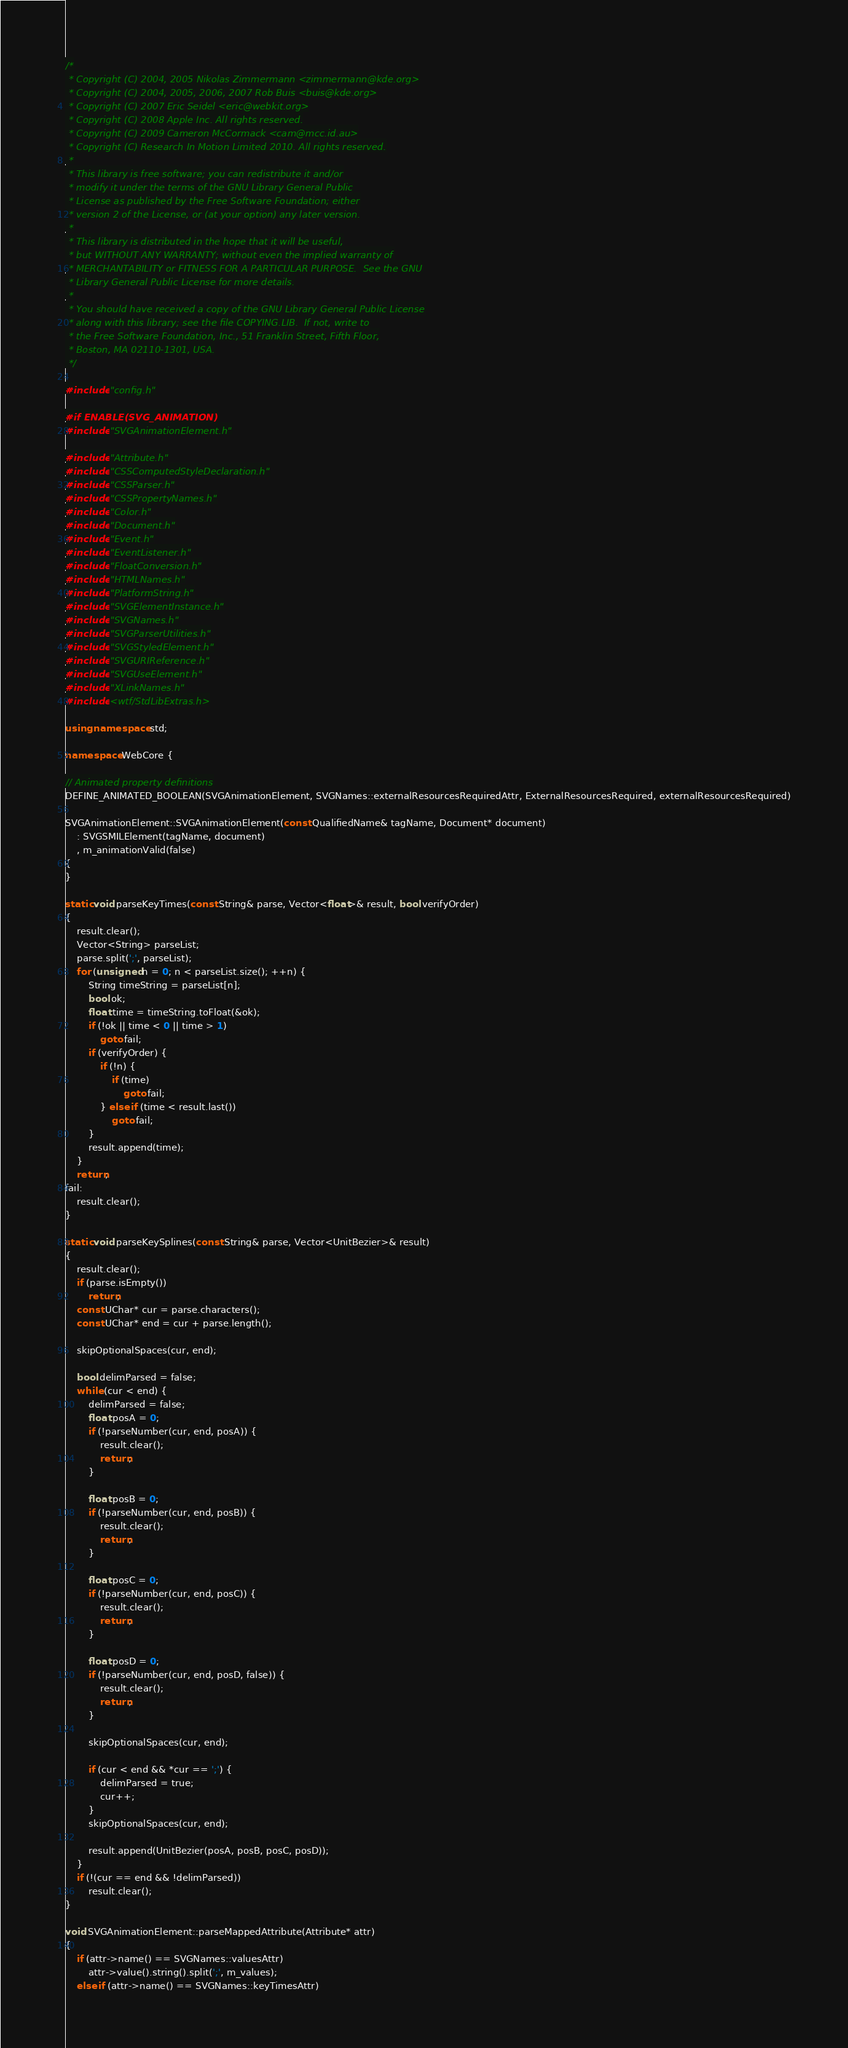<code> <loc_0><loc_0><loc_500><loc_500><_C++_>/*
 * Copyright (C) 2004, 2005 Nikolas Zimmermann <zimmermann@kde.org>
 * Copyright (C) 2004, 2005, 2006, 2007 Rob Buis <buis@kde.org>
 * Copyright (C) 2007 Eric Seidel <eric@webkit.org>
 * Copyright (C) 2008 Apple Inc. All rights reserved.
 * Copyright (C) 2009 Cameron McCormack <cam@mcc.id.au>
 * Copyright (C) Research In Motion Limited 2010. All rights reserved.
 *
 * This library is free software; you can redistribute it and/or
 * modify it under the terms of the GNU Library General Public
 * License as published by the Free Software Foundation; either
 * version 2 of the License, or (at your option) any later version.
 *
 * This library is distributed in the hope that it will be useful,
 * but WITHOUT ANY WARRANTY; without even the implied warranty of
 * MERCHANTABILITY or FITNESS FOR A PARTICULAR PURPOSE.  See the GNU
 * Library General Public License for more details.
 *
 * You should have received a copy of the GNU Library General Public License
 * along with this library; see the file COPYING.LIB.  If not, write to
 * the Free Software Foundation, Inc., 51 Franklin Street, Fifth Floor,
 * Boston, MA 02110-1301, USA.
 */

#include "config.h"

#if ENABLE(SVG_ANIMATION)
#include "SVGAnimationElement.h"

#include "Attribute.h"
#include "CSSComputedStyleDeclaration.h"
#include "CSSParser.h"
#include "CSSPropertyNames.h"
#include "Color.h"
#include "Document.h"
#include "Event.h"
#include "EventListener.h"
#include "FloatConversion.h"
#include "HTMLNames.h"
#include "PlatformString.h"
#include "SVGElementInstance.h"
#include "SVGNames.h"
#include "SVGParserUtilities.h"
#include "SVGStyledElement.h"
#include "SVGURIReference.h"
#include "SVGUseElement.h"
#include "XLinkNames.h"
#include <wtf/StdLibExtras.h>

using namespace std;

namespace WebCore {

// Animated property definitions
DEFINE_ANIMATED_BOOLEAN(SVGAnimationElement, SVGNames::externalResourcesRequiredAttr, ExternalResourcesRequired, externalResourcesRequired)

SVGAnimationElement::SVGAnimationElement(const QualifiedName& tagName, Document* document)
    : SVGSMILElement(tagName, document)
    , m_animationValid(false)
{
}

static void parseKeyTimes(const String& parse, Vector<float>& result, bool verifyOrder)
{
    result.clear();
    Vector<String> parseList;
    parse.split(';', parseList);
    for (unsigned n = 0; n < parseList.size(); ++n) {
        String timeString = parseList[n];
        bool ok;
        float time = timeString.toFloat(&ok);
        if (!ok || time < 0 || time > 1)
            goto fail;
        if (verifyOrder) {
            if (!n) {
                if (time)
                    goto fail;
            } else if (time < result.last())
                goto fail;
        }
        result.append(time);
    }
    return;
fail:
    result.clear();
}

static void parseKeySplines(const String& parse, Vector<UnitBezier>& result)
{
    result.clear();
    if (parse.isEmpty())
        return;
    const UChar* cur = parse.characters();
    const UChar* end = cur + parse.length();

    skipOptionalSpaces(cur, end);

    bool delimParsed = false;
    while (cur < end) {
        delimParsed = false;
        float posA = 0;
        if (!parseNumber(cur, end, posA)) {
            result.clear();
            return;
        }

        float posB = 0;
        if (!parseNumber(cur, end, posB)) {
            result.clear();
            return;
        }

        float posC = 0;
        if (!parseNumber(cur, end, posC)) {
            result.clear();
            return;
        }

        float posD = 0;
        if (!parseNumber(cur, end, posD, false)) {
            result.clear();
            return;
        }

        skipOptionalSpaces(cur, end);

        if (cur < end && *cur == ';') {
            delimParsed = true;
            cur++;
        }
        skipOptionalSpaces(cur, end);

        result.append(UnitBezier(posA, posB, posC, posD));
    }
    if (!(cur == end && !delimParsed))
        result.clear();
}

void SVGAnimationElement::parseMappedAttribute(Attribute* attr)
{
    if (attr->name() == SVGNames::valuesAttr)
        attr->value().string().split(';', m_values);
    else if (attr->name() == SVGNames::keyTimesAttr)</code> 